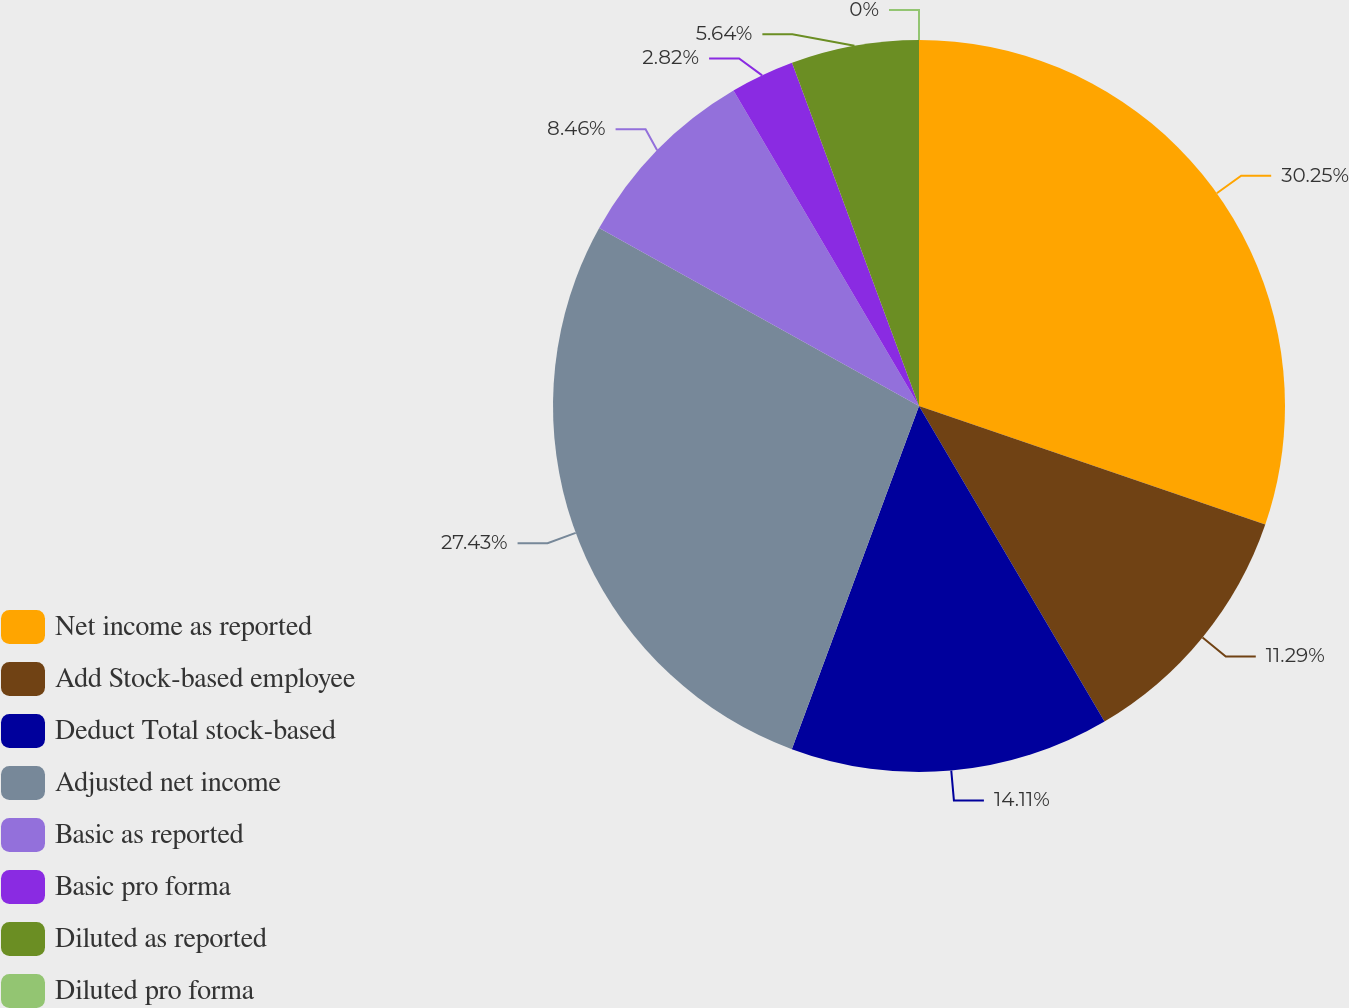<chart> <loc_0><loc_0><loc_500><loc_500><pie_chart><fcel>Net income as reported<fcel>Add Stock-based employee<fcel>Deduct Total stock-based<fcel>Adjusted net income<fcel>Basic as reported<fcel>Basic pro forma<fcel>Diluted as reported<fcel>Diluted pro forma<nl><fcel>30.25%<fcel>11.29%<fcel>14.11%<fcel>27.43%<fcel>8.46%<fcel>2.82%<fcel>5.64%<fcel>0.0%<nl></chart> 